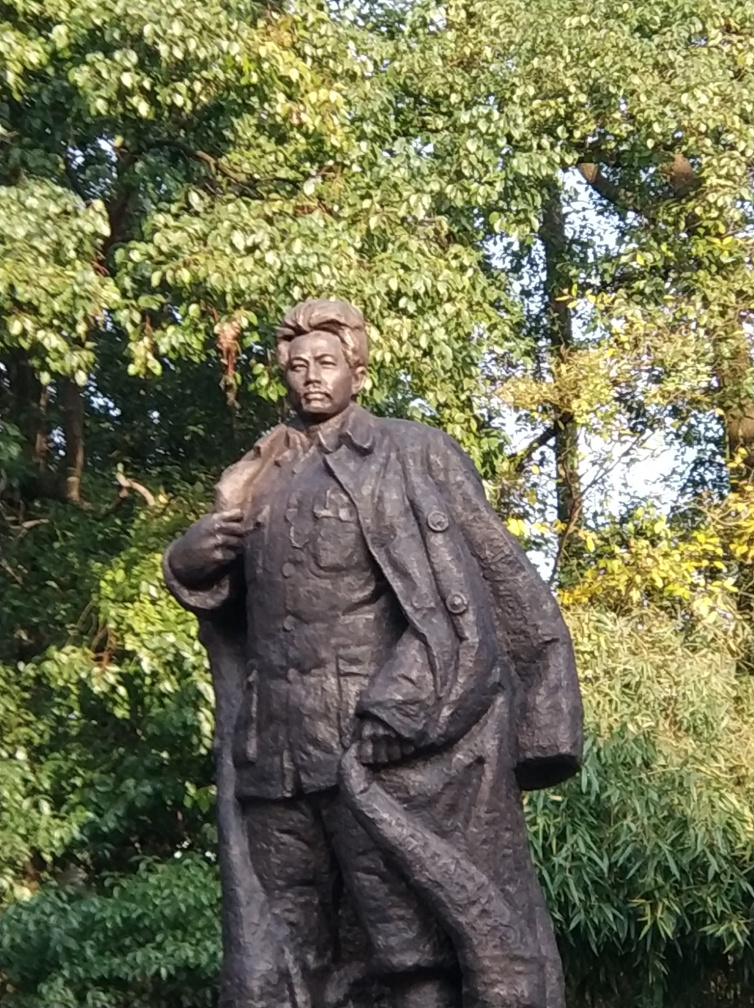Can you describe the setting in which the statue is placed? Certainly. The statue is set against a verdant environment, standing prominently amidst a backdrop of dense green foliage. This provides a serene and natural atmosphere which contrasts with the rigidity and permanence of the bronze sculpture. The placement within a well-vegetated area might signify a location of tranquility and respect, suitable for contemplation or commemoration of the figure portrayed. 